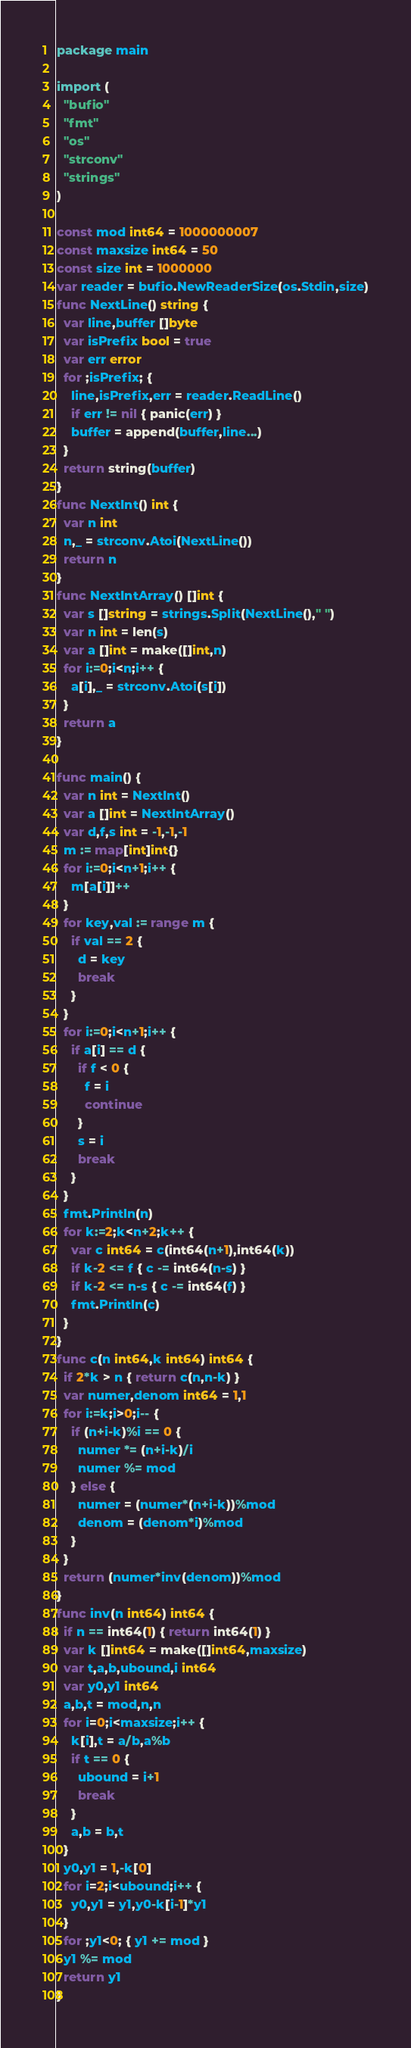Convert code to text. <code><loc_0><loc_0><loc_500><loc_500><_Go_>package main

import (
  "bufio"
  "fmt"
  "os"
  "strconv"
  "strings"
)

const mod int64 = 1000000007
const maxsize int64 = 50
const size int = 1000000
var reader = bufio.NewReaderSize(os.Stdin,size)
func NextLine() string {
  var line,buffer []byte
  var isPrefix bool = true
  var err error
  for ;isPrefix; {
    line,isPrefix,err = reader.ReadLine()
    if err != nil { panic(err) }
    buffer = append(buffer,line...)
  }
  return string(buffer)
}
func NextInt() int {
  var n int
  n,_ = strconv.Atoi(NextLine())
  return n
}
func NextIntArray() []int {
  var s []string = strings.Split(NextLine()," ")
  var n int = len(s)
  var a []int = make([]int,n)
  for i:=0;i<n;i++ {
    a[i],_ = strconv.Atoi(s[i])
  }
  return a
}

func main() {
  var n int = NextInt()
  var a []int = NextIntArray()
  var d,f,s int = -1,-1,-1
  m := map[int]int{}
  for i:=0;i<n+1;i++ {
    m[a[i]]++
  }
  for key,val := range m {
    if val == 2 {
      d = key
      break
    }
  }
  for i:=0;i<n+1;i++ {
    if a[i] == d {
      if f < 0 {
        f = i
        continue
      }
      s = i
      break
    }
  }
  fmt.Println(n)
  for k:=2;k<n+2;k++ {
    var c int64 = c(int64(n+1),int64(k))
    if k-2 <= f { c -= int64(n-s) }
    if k-2 <= n-s { c -= int64(f) }
    fmt.Println(c)
  }
}
func c(n int64,k int64) int64 {
  if 2*k > n { return c(n,n-k) }
  var numer,denom int64 = 1,1
  for i:=k;i>0;i-- {
    if (n+i-k)%i == 0 {
      numer *= (n+i-k)/i
      numer %= mod
    } else {
      numer = (numer*(n+i-k))%mod
      denom = (denom*i)%mod
    }
  }
  return (numer*inv(denom))%mod
}
func inv(n int64) int64 {
  if n == int64(1) { return int64(1) }
  var k []int64 = make([]int64,maxsize)
  var t,a,b,ubound,i int64
  var y0,y1 int64
  a,b,t = mod,n,n
  for i=0;i<maxsize;i++ {
    k[i],t = a/b,a%b
    if t == 0 {
      ubound = i+1
      break
    }
    a,b = b,t
  }
  y0,y1 = 1,-k[0]
  for i=2;i<ubound;i++ {
    y0,y1 = y1,y0-k[i-1]*y1
  }
  for ;y1<0; { y1 += mod }
  y1 %= mod
  return y1
}</code> 